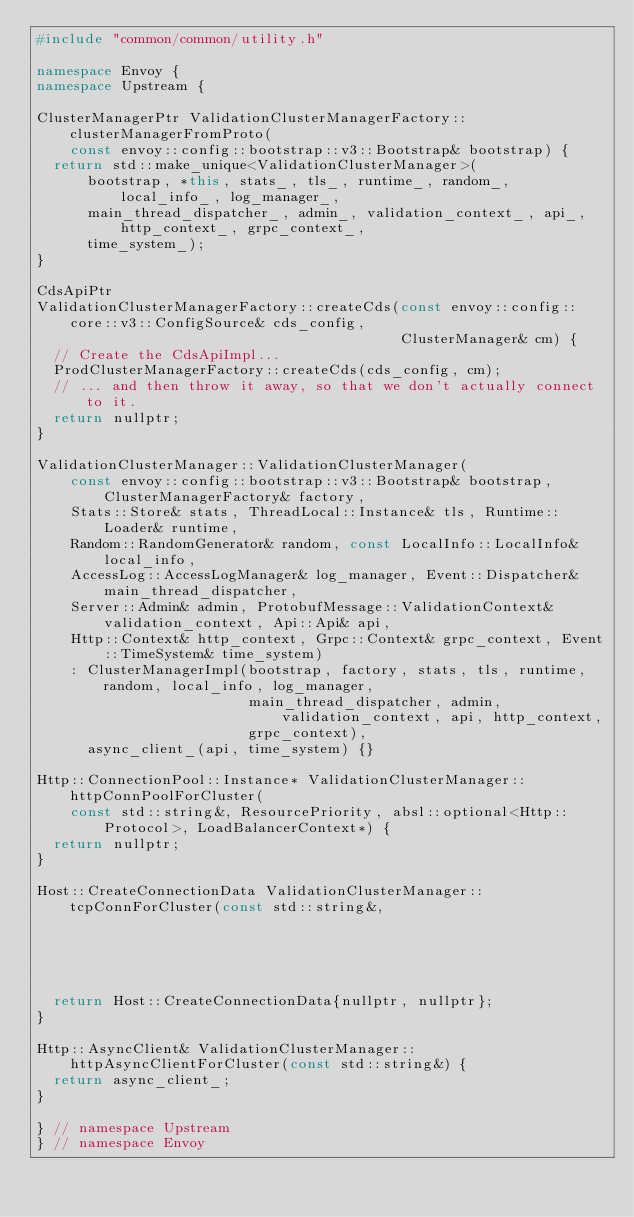<code> <loc_0><loc_0><loc_500><loc_500><_C++_>#include "common/common/utility.h"

namespace Envoy {
namespace Upstream {

ClusterManagerPtr ValidationClusterManagerFactory::clusterManagerFromProto(
    const envoy::config::bootstrap::v3::Bootstrap& bootstrap) {
  return std::make_unique<ValidationClusterManager>(
      bootstrap, *this, stats_, tls_, runtime_, random_, local_info_, log_manager_,
      main_thread_dispatcher_, admin_, validation_context_, api_, http_context_, grpc_context_,
      time_system_);
}

CdsApiPtr
ValidationClusterManagerFactory::createCds(const envoy::config::core::v3::ConfigSource& cds_config,
                                           ClusterManager& cm) {
  // Create the CdsApiImpl...
  ProdClusterManagerFactory::createCds(cds_config, cm);
  // ... and then throw it away, so that we don't actually connect to it.
  return nullptr;
}

ValidationClusterManager::ValidationClusterManager(
    const envoy::config::bootstrap::v3::Bootstrap& bootstrap, ClusterManagerFactory& factory,
    Stats::Store& stats, ThreadLocal::Instance& tls, Runtime::Loader& runtime,
    Random::RandomGenerator& random, const LocalInfo::LocalInfo& local_info,
    AccessLog::AccessLogManager& log_manager, Event::Dispatcher& main_thread_dispatcher,
    Server::Admin& admin, ProtobufMessage::ValidationContext& validation_context, Api::Api& api,
    Http::Context& http_context, Grpc::Context& grpc_context, Event::TimeSystem& time_system)
    : ClusterManagerImpl(bootstrap, factory, stats, tls, runtime, random, local_info, log_manager,
                         main_thread_dispatcher, admin, validation_context, api, http_context,
                         grpc_context),
      async_client_(api, time_system) {}

Http::ConnectionPool::Instance* ValidationClusterManager::httpConnPoolForCluster(
    const std::string&, ResourcePriority, absl::optional<Http::Protocol>, LoadBalancerContext*) {
  return nullptr;
}

Host::CreateConnectionData ValidationClusterManager::tcpConnForCluster(const std::string&,
                                                                       LoadBalancerContext*) {
  return Host::CreateConnectionData{nullptr, nullptr};
}

Http::AsyncClient& ValidationClusterManager::httpAsyncClientForCluster(const std::string&) {
  return async_client_;
}

} // namespace Upstream
} // namespace Envoy
</code> 